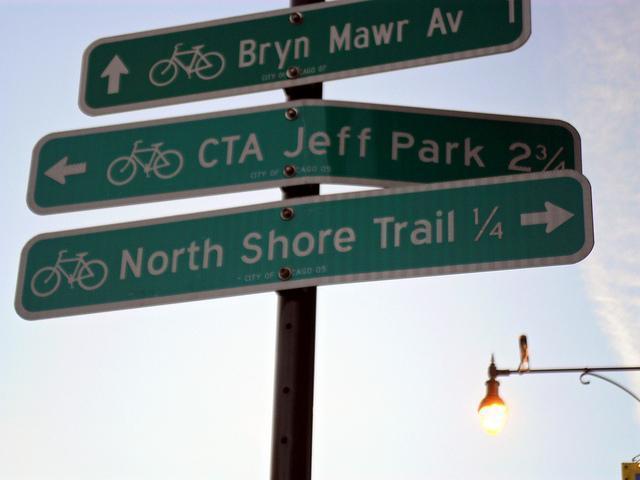How many signs are shown?
Give a very brief answer. 3. 